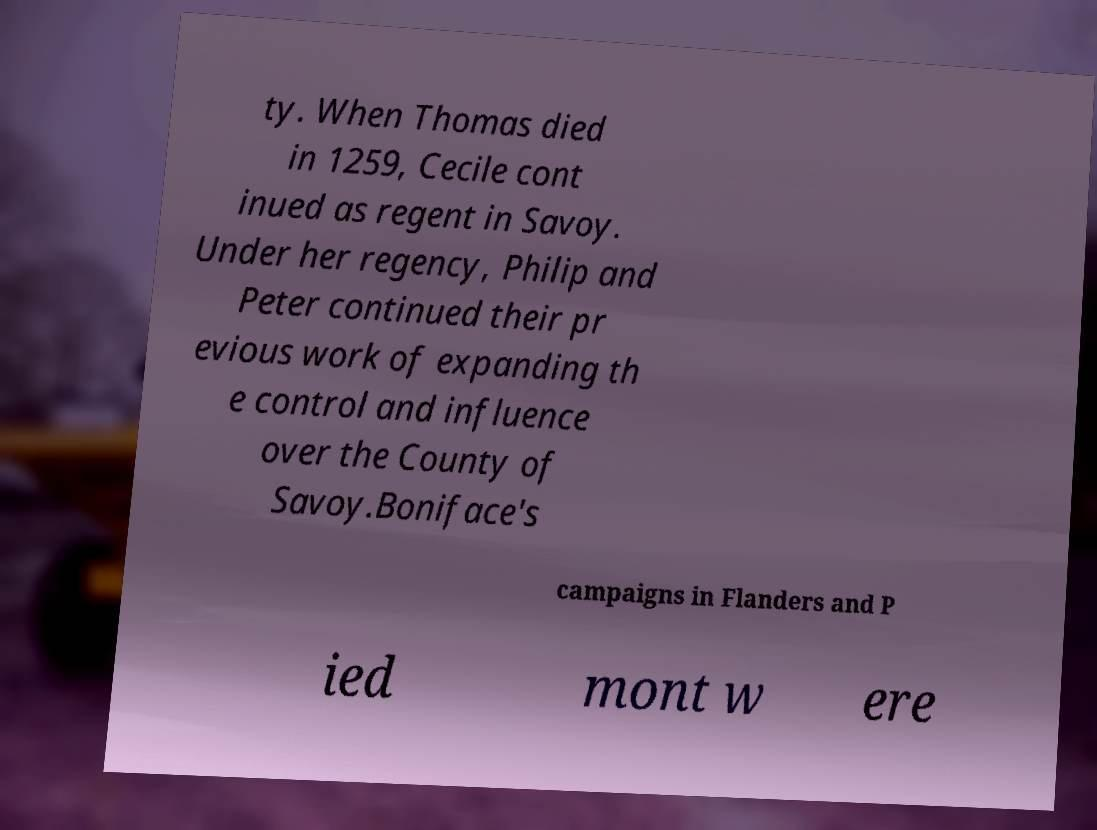Could you extract and type out the text from this image? ty. When Thomas died in 1259, Cecile cont inued as regent in Savoy. Under her regency, Philip and Peter continued their pr evious work of expanding th e control and influence over the County of Savoy.Boniface's campaigns in Flanders and P ied mont w ere 